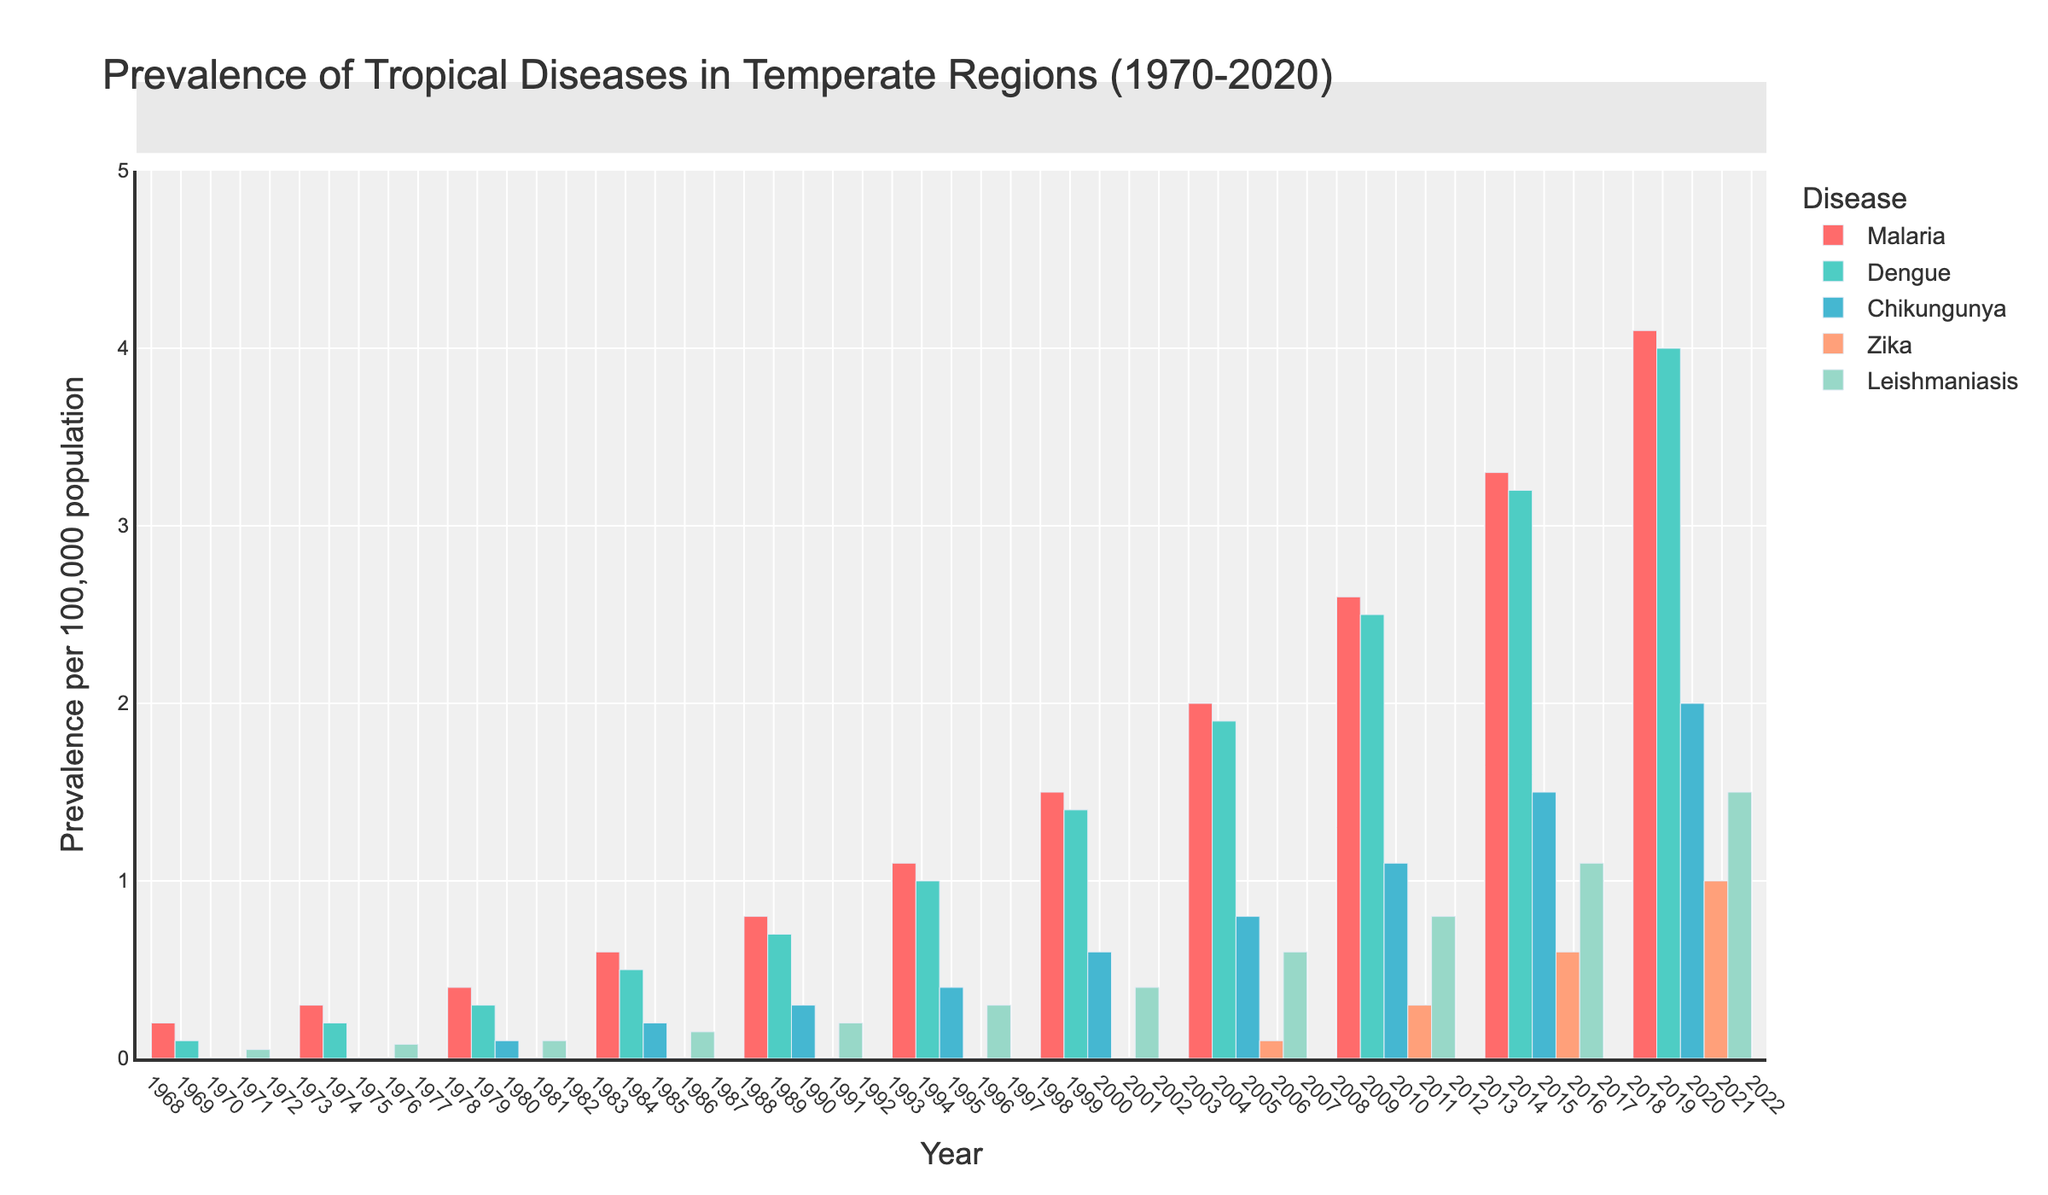What is the prevalence of Malaria in 1980 compared to Dengue in the same year? To find the answer, look at the height of the bars for Malaria and Dengue in the year 1980. The Malaria bar shows a prevalence of 0.4, while the Dengue bar shows a prevalence of 0.3. Compare these two values.
Answer: Malaria is higher than Dengue How has the prevalence of Zika changed from 2005 to 2020? Check the heights of the Zika bars for the years 2005 and 2020. In 2005, the height corresponds to a prevalence of 0.1. By 2020, this height has increased to 1.0. Calculate the difference: 1.0 - 0.1 = 0.9.
Answer: Increased by 0.9 Which disease had the highest prevalence in 2015? Look at all the bars for the year 2015 and identify the one with the greatest height. The bars correspond to Malaria, Dengue, Chikungunya, Zika, and Leishmaniasis with respective heights of 3.3, 3.2, 1.5, 0.6, and 1.1. The Malaria bar is the tallest.
Answer: Malaria What is the trend in the prevalence of Chikungunya from 1970 to 2020? Observe the heights of the Chikungunya bars across all the years. Chikungunya starts at 0 in 1970, rises gradually, and reaches a height of 2.0 in 2020. This shows a continuously increasing trend.
Answer: Increasing Find the total prevalence of Leishmaniasis from 1970 to 2020. Sum the heights of the Leishmaniasis bars for all the years: 0.05 + 0.08 + 0.1 + 0.15 + 0.2 + 0.3 + 0.4 + 0.6 + 0.8 + 1.1 + 1.5 = 5.28.
Answer: 5.28 Which two diseases have the closest prevalence values in 1995? Compare the heights of all the bars for 1995. Malaria (1.1), Dengue (1.0), Chikungunya (0.4), Zika (0), and Leishmaniasis (0.3). Malaria and Dengue have the closest values, with a difference of 0.1 (1.1 - 1.0).
Answer: Malaria and Dengue How does the prevalence of Malaria in 1970 compare to its prevalence in 2020? Check the heights of the Malaria bars for the years 1970 and 2020. In 1970, the height is 0.2, and in 2020, it is 4.1. Calculate the difference: 4.1 - 0.2 = 3.9.
Answer: Increased by 3.9 What is the average prevalence of Dengue between 1980 and 2000 (inclusive)? Identify the Dengue bars from 1980 to 2000: 0.3, 0.5, 0.7, 1.0, and 1.4. Calculate the average: (0.3 + 0.5 + 0.7 + 1.0 + 1.4) / 5 = 3.9 / 5 = 0.78.
Answer: 0.78 